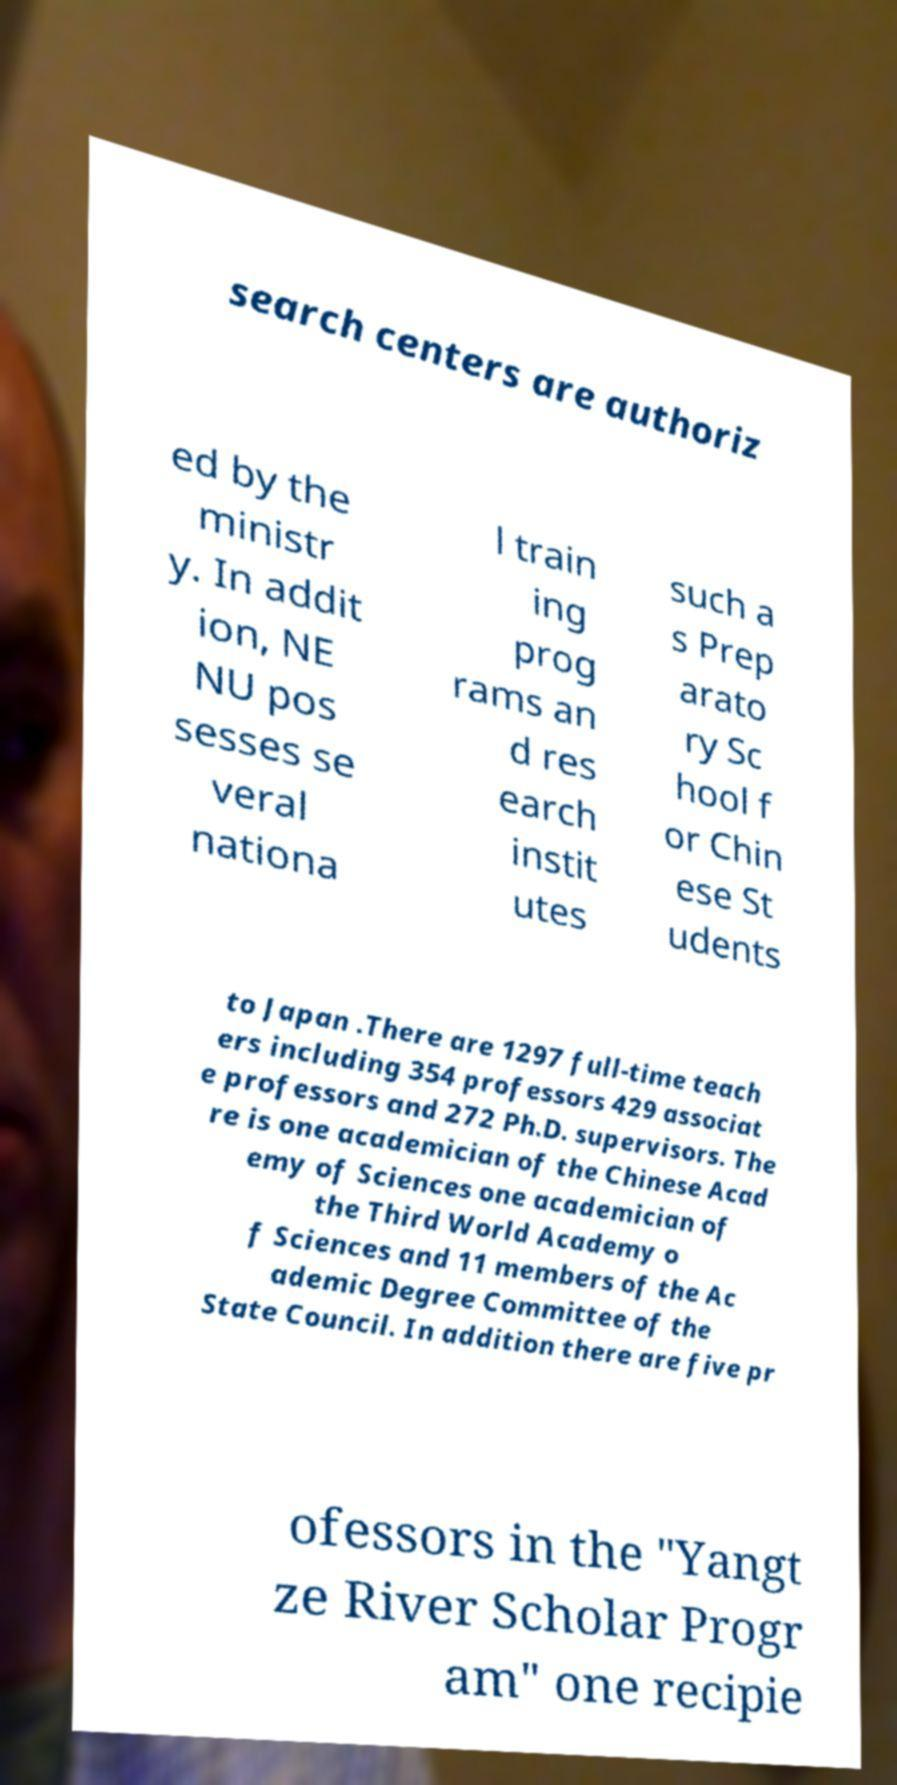Could you extract and type out the text from this image? search centers are authoriz ed by the ministr y. In addit ion, NE NU pos sesses se veral nationa l train ing prog rams an d res earch instit utes such a s Prep arato ry Sc hool f or Chin ese St udents to Japan .There are 1297 full-time teach ers including 354 professors 429 associat e professors and 272 Ph.D. supervisors. The re is one academician of the Chinese Acad emy of Sciences one academician of the Third World Academy o f Sciences and 11 members of the Ac ademic Degree Committee of the State Council. In addition there are five pr ofessors in the "Yangt ze River Scholar Progr am" one recipie 